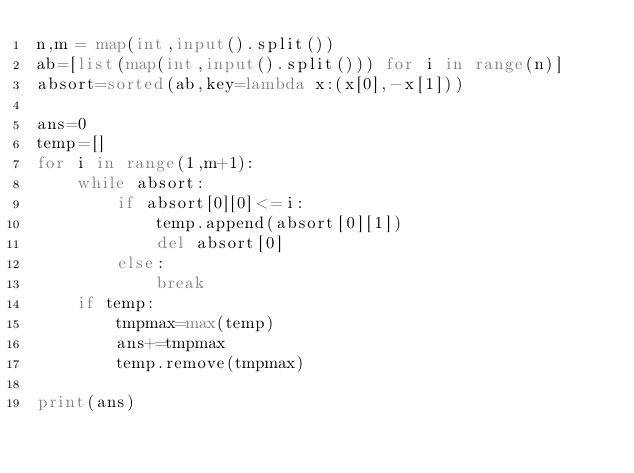Convert code to text. <code><loc_0><loc_0><loc_500><loc_500><_Python_>n,m = map(int,input().split())
ab=[list(map(int,input().split())) for i in range(n)]
absort=sorted(ab,key=lambda x:(x[0],-x[1]))

ans=0
temp=[]
for i in range(1,m+1):
    while absort:
        if absort[0][0]<=i:
            temp.append(absort[0][1])
            del absort[0]
        else:
            break
    if temp:
        tmpmax=max(temp)
        ans+=tmpmax
        temp.remove(tmpmax)

print(ans)
</code> 